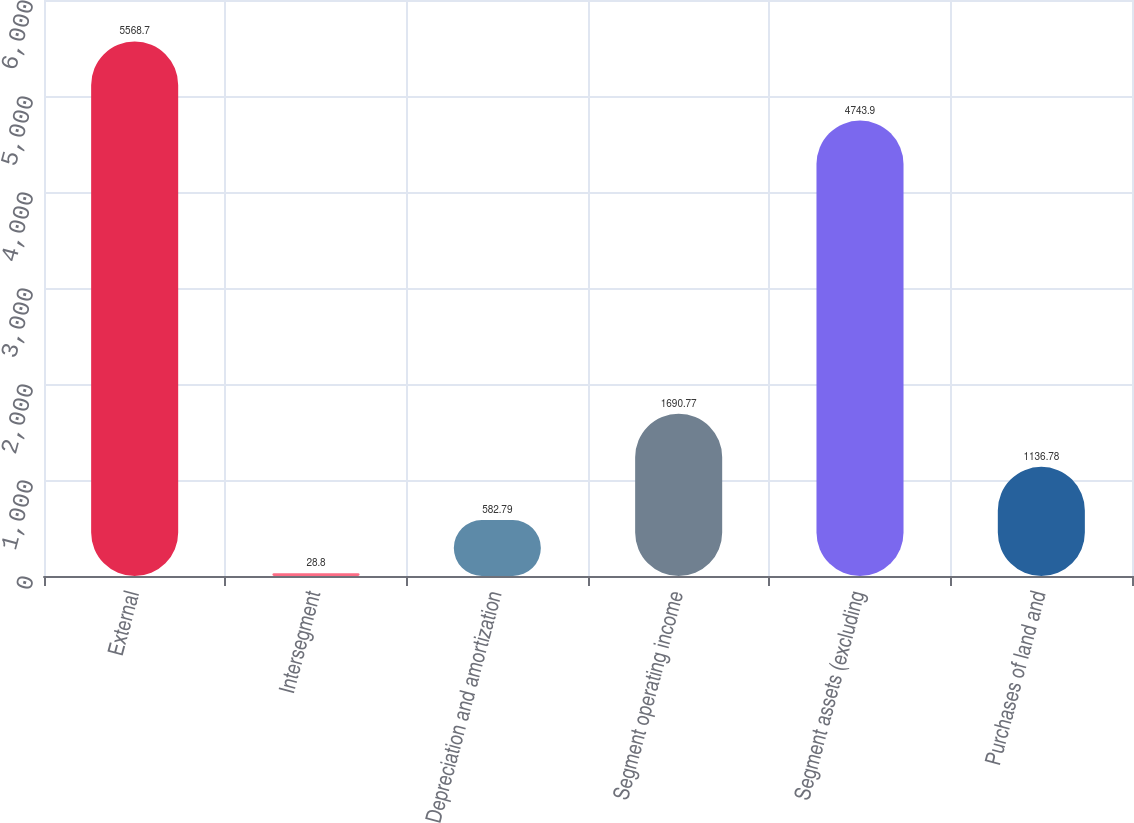Convert chart. <chart><loc_0><loc_0><loc_500><loc_500><bar_chart><fcel>External<fcel>Intersegment<fcel>Depreciation and amortization<fcel>Segment operating income<fcel>Segment assets (excluding<fcel>Purchases of land and<nl><fcel>5568.7<fcel>28.8<fcel>582.79<fcel>1690.77<fcel>4743.9<fcel>1136.78<nl></chart> 